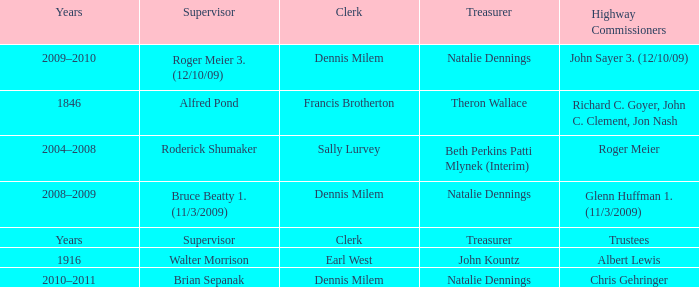Who was the supervisor in the year 1846? Alfred Pond. 